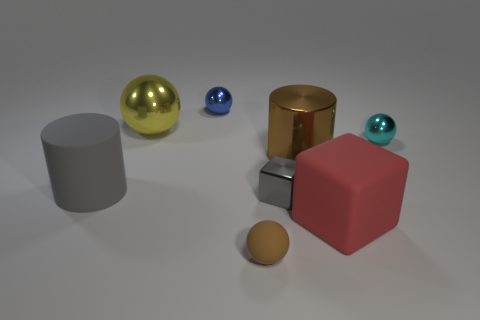There is a metallic thing that is the same shape as the big red rubber object; what is its color?
Offer a terse response. Gray. Is the color of the big thing that is left of the big metallic ball the same as the large metal cylinder?
Make the answer very short. No. Are there any brown objects in front of the matte cube?
Make the answer very short. Yes. What color is the rubber object that is on the left side of the rubber cube and in front of the big gray rubber cylinder?
Provide a succinct answer. Brown. The object that is the same color as the large metallic cylinder is what shape?
Your response must be concise. Sphere. What size is the sphere that is in front of the large rubber thing that is to the left of the blue metal sphere?
Provide a succinct answer. Small. How many balls are big gray rubber things or gray metallic things?
Keep it short and to the point. 0. What color is the metallic object that is the same size as the yellow ball?
Offer a terse response. Brown. There is a metal thing in front of the large cylinder on the left side of the big yellow thing; what shape is it?
Make the answer very short. Cube. There is a metal thing in front of the gray cylinder; does it have the same size as the brown ball?
Offer a terse response. Yes. 